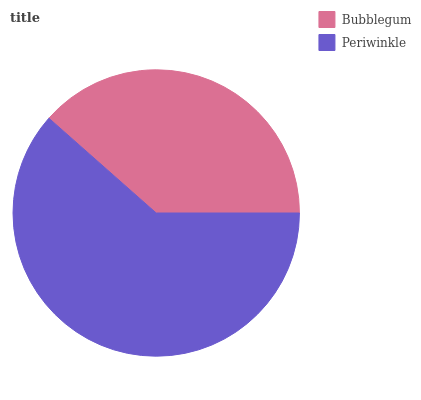Is Bubblegum the minimum?
Answer yes or no. Yes. Is Periwinkle the maximum?
Answer yes or no. Yes. Is Periwinkle the minimum?
Answer yes or no. No. Is Periwinkle greater than Bubblegum?
Answer yes or no. Yes. Is Bubblegum less than Periwinkle?
Answer yes or no. Yes. Is Bubblegum greater than Periwinkle?
Answer yes or no. No. Is Periwinkle less than Bubblegum?
Answer yes or no. No. Is Periwinkle the high median?
Answer yes or no. Yes. Is Bubblegum the low median?
Answer yes or no. Yes. Is Bubblegum the high median?
Answer yes or no. No. Is Periwinkle the low median?
Answer yes or no. No. 